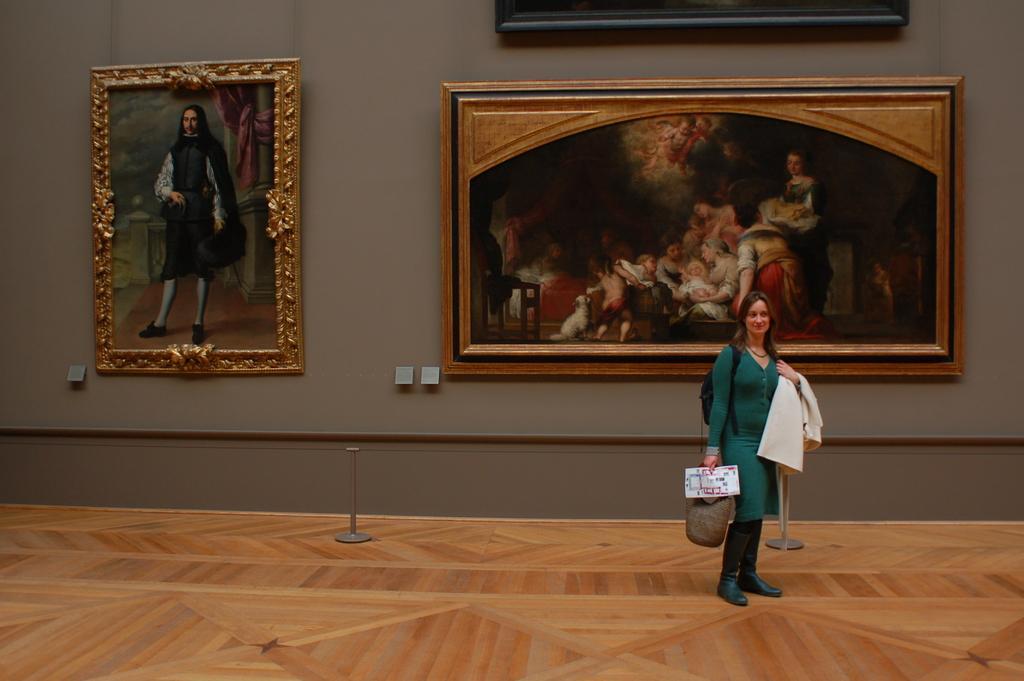In one or two sentences, can you explain what this image depicts? In the image there is a lady holding a bag and jacket in her hand. Behind her there are few poles. And there are is a wall with few frames. 